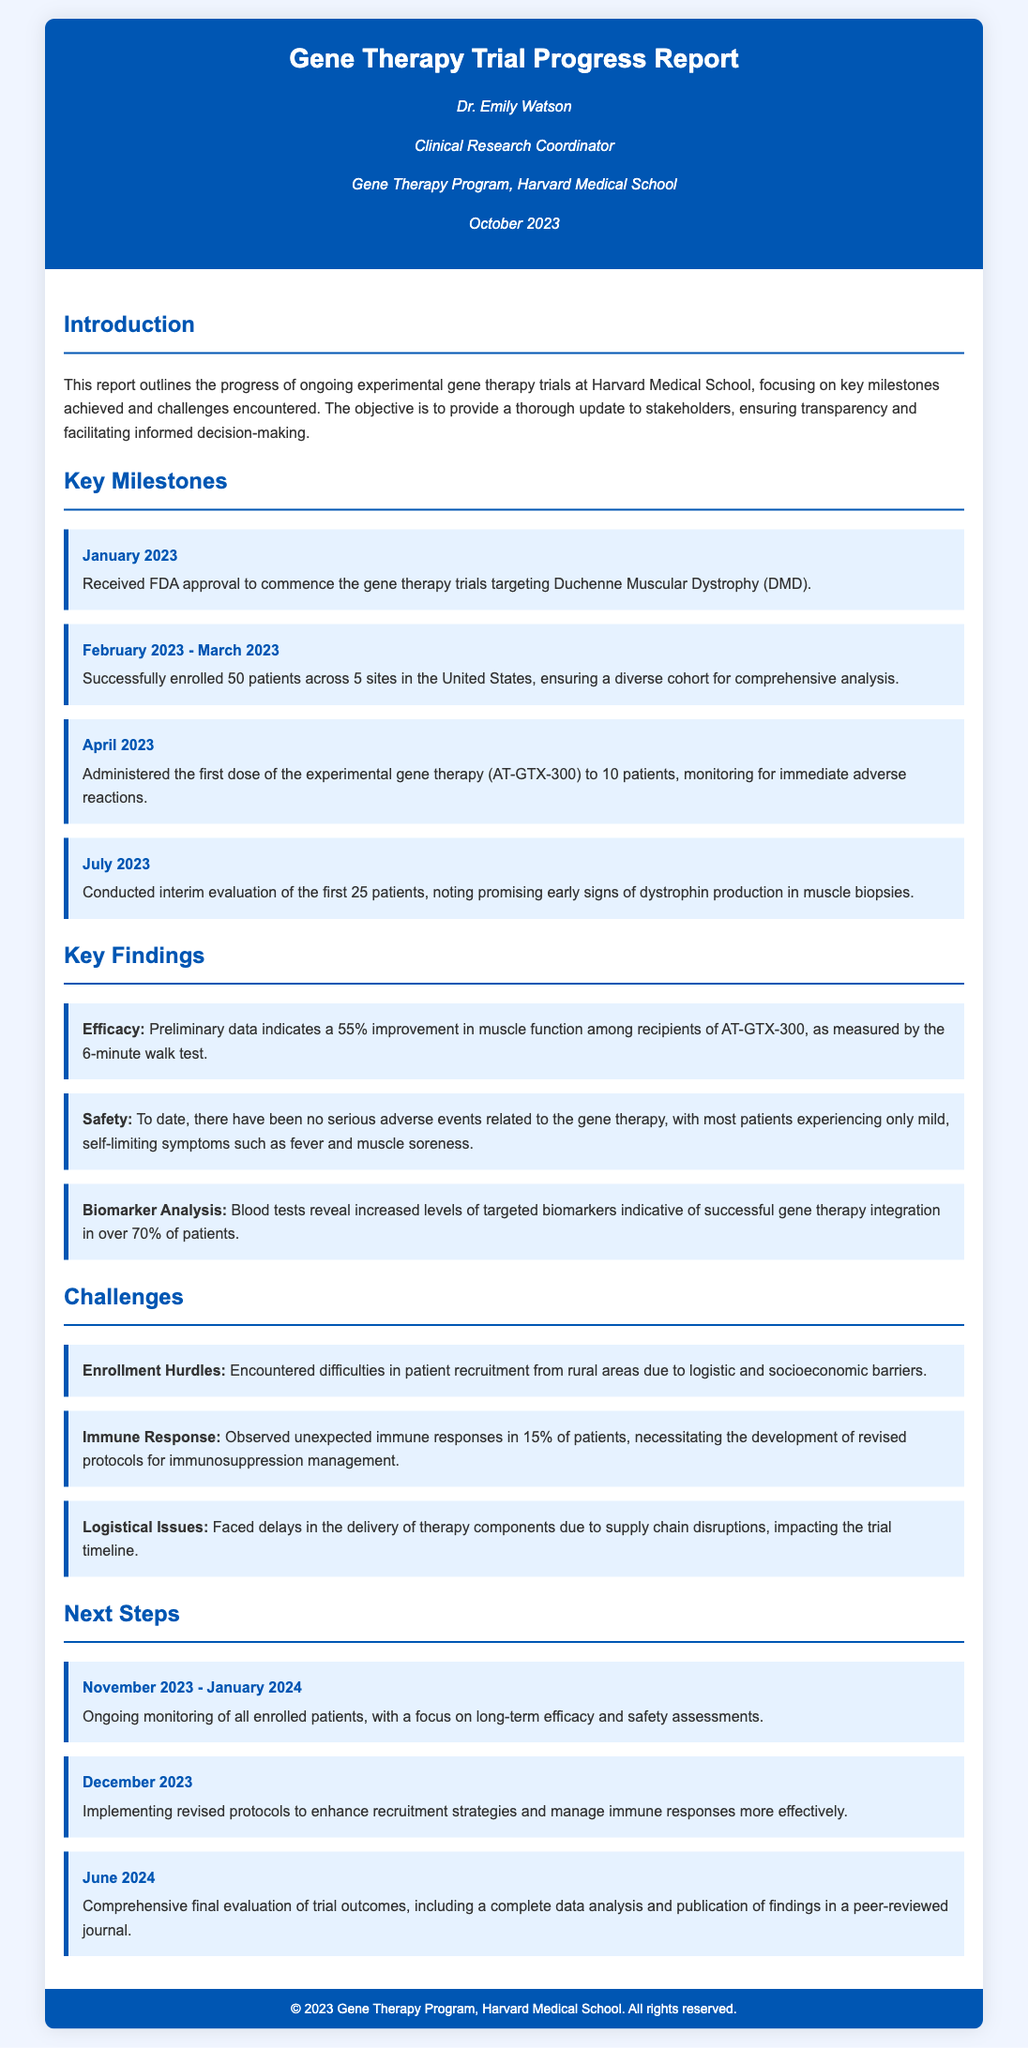What is the title of the report? The title of the report is stated in the header section of the document.
Answer: Gene Therapy Trial Progress Report Who is the author of the report? The author's name is featured in the author information section.
Answer: Dr. Emily Watson When was the FDA approval received? The date of the FDA approval is listed as a key milestone in the document.
Answer: January 2023 How many patients were enrolled in the trials? The total number of enrolled patients is provided under key milestones.
Answer: 50 patients What percentage improvement in muscle function was reported? The improvement percentage is described under key findings in relation to the efficacy of the gene therapy.
Answer: 55% How many sites were involved in patient enrollment? The number of sites is included in the summary of patient enrollment milestones.
Answer: 5 sites What unexpected issue was observed in 15% of patients? The issue is specified under key challenges faced during the trials.
Answer: Immune responses What is the next step planned for November 2023? The next step is included in the next steps section detailing ongoing activities.
Answer: Ongoing monitoring of all enrolled patients What is the primary focus of the upcoming evaluation in June 2024? The primary focus is outlined in the future plans of the document.
Answer: Comprehensive final evaluation of trial outcomes 